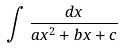Convert formula to latex. <formula><loc_0><loc_0><loc_500><loc_500>\int \frac { d x } { a x ^ { 2 } + b x + c }</formula> 